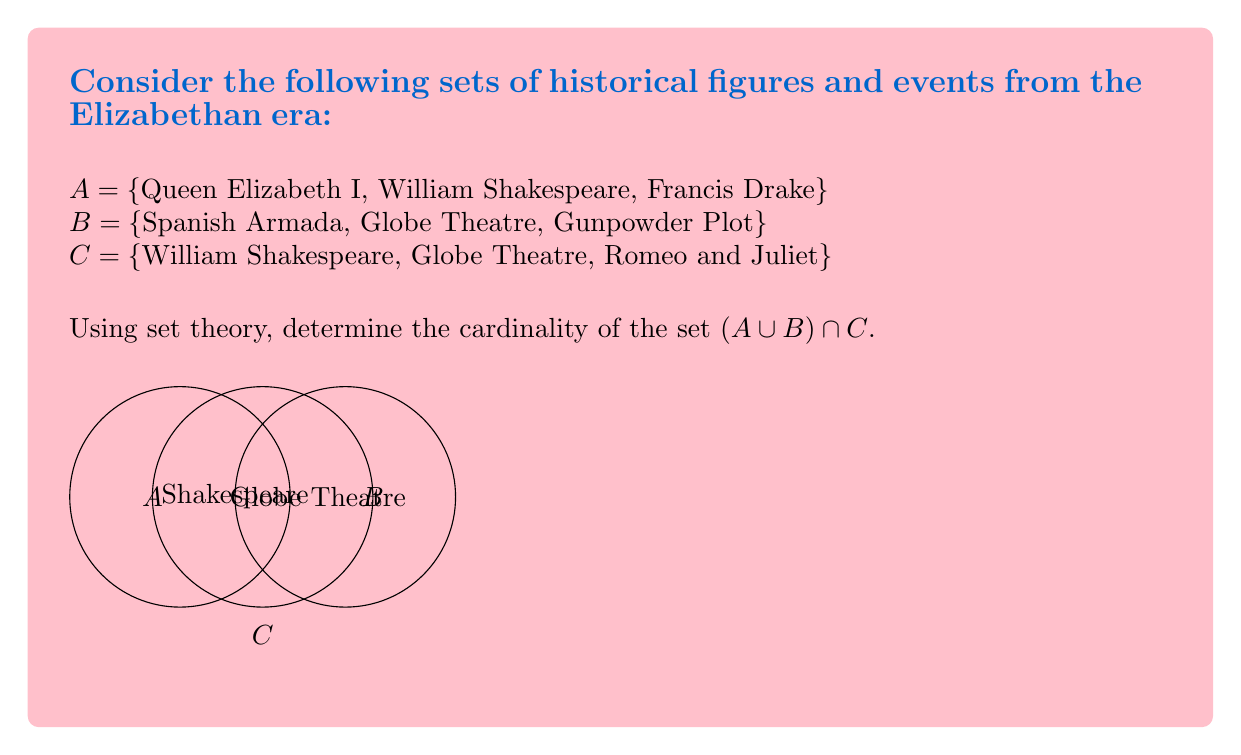Show me your answer to this math problem. Let's approach this step-by-step:

1) First, we need to find $A \cup B$:
   $A \cup B = \{$Queen Elizabeth I, William Shakespeare, Francis Drake, Spanish Armada, Globe Theatre, Gunpowder Plot$\}$

2) Now, we need to find the intersection of this set with C:
   $(A \cup B) \cap C = \{$William Shakespeare, Globe Theatre$\}$

3) The cardinality of a set is the number of elements in the set. We can denote this using vertical bars: $|(A \cup B) \cap C|$

4) Counting the elements in our final set:
   $|(A \cup B) \cap C| = |\{$William Shakespeare, Globe Theatre$\}| = 2$

This result aligns with the Venn diagram, where we can see that "Shakespeare" and "Globe Theatre" are the only elements in the intersection of all three sets.
Answer: $2$ 